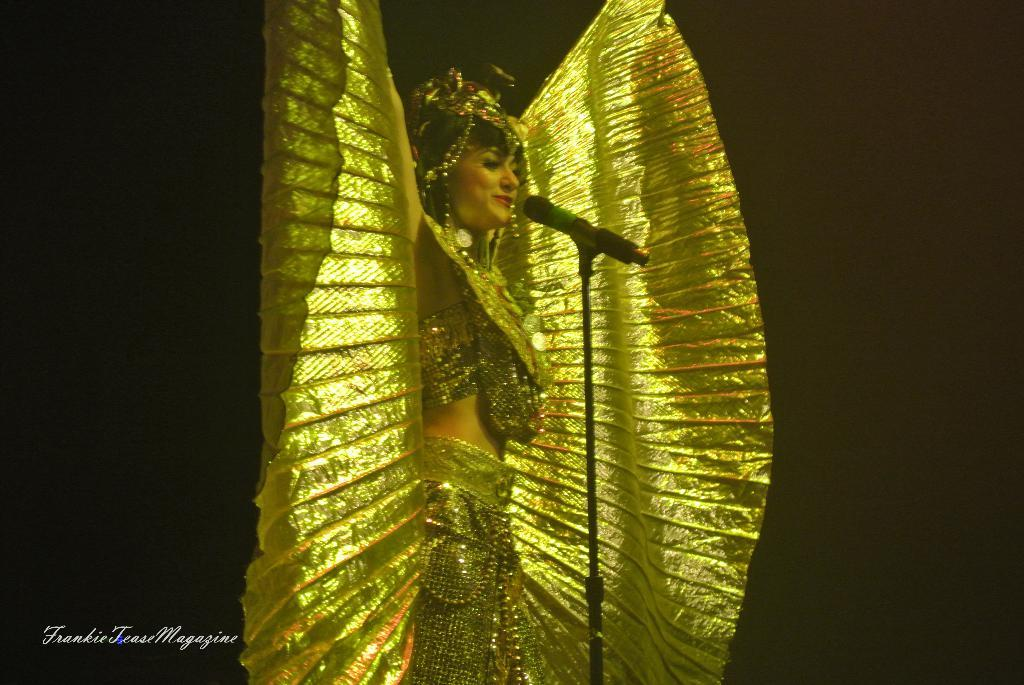Who is the main subject in the image? There is a lady in the image. What is the lady wearing? The lady is wearing a costume. What object is in front of the lady? There is a microphone (mike) in front of the lady. What can be seen at the bottom of the image? There is some text at the bottom of the image. What type of growth can be seen on the lady's costume in the image? There is no growth visible on the lady's costume in the image. Is the lady an actor in the image? The provided facts do not mention whether the lady is an actor or not, so we cannot definitively answer this question. 